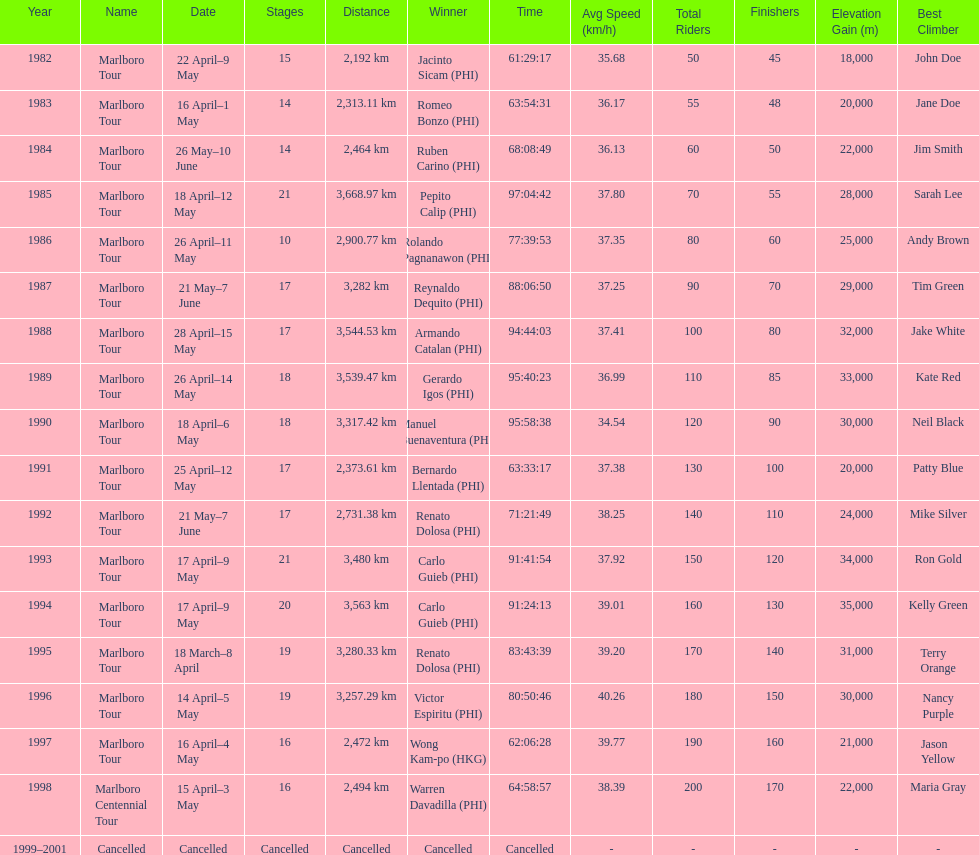What race did warren davadilla compete in in 1998? Marlboro Centennial Tour. How long did it take davadilla to complete the marlboro centennial tour? 64:58:57. 